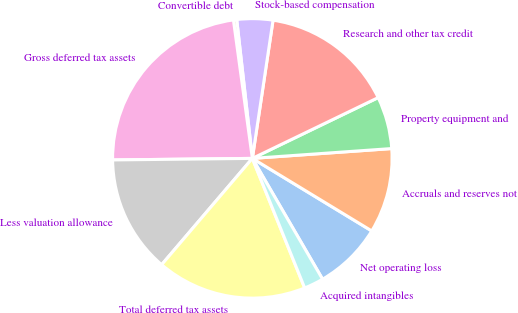<chart> <loc_0><loc_0><loc_500><loc_500><pie_chart><fcel>Net operating loss<fcel>Accruals and reserves not<fcel>Property equipment and<fcel>Research and other tax credit<fcel>Stock-based compensation<fcel>Convertible debt<fcel>Gross deferred tax assets<fcel>Less valuation allowance<fcel>Total deferred tax assets<fcel>Acquired intangibles<nl><fcel>7.93%<fcel>9.81%<fcel>6.04%<fcel>15.47%<fcel>4.15%<fcel>0.38%<fcel>23.01%<fcel>13.58%<fcel>17.35%<fcel>2.27%<nl></chart> 